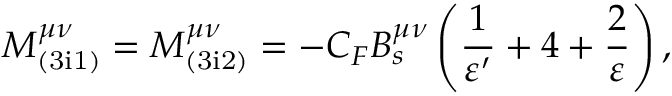<formula> <loc_0><loc_0><loc_500><loc_500>M _ { ( 3 i 1 ) } ^ { \mu \nu } = M _ { ( 3 i 2 ) } ^ { \mu \nu } = - C _ { F } B _ { s } ^ { \mu \nu } \left ( \frac { 1 } { \varepsilon ^ { \prime } } + 4 + \frac { 2 } { \varepsilon } \right ) ,</formula> 